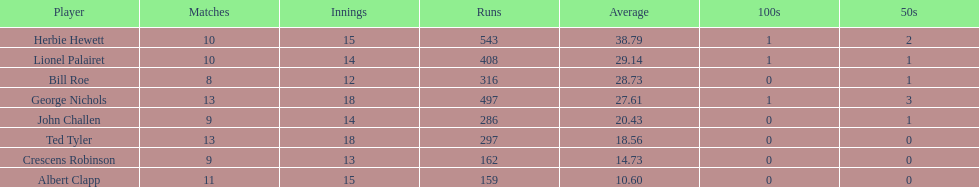Which player had the least amount of runs? Albert Clapp. 